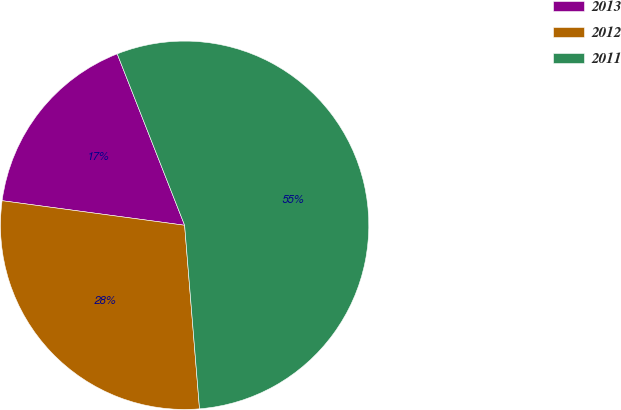<chart> <loc_0><loc_0><loc_500><loc_500><pie_chart><fcel>2013<fcel>2012<fcel>2011<nl><fcel>16.91%<fcel>28.42%<fcel>54.68%<nl></chart> 